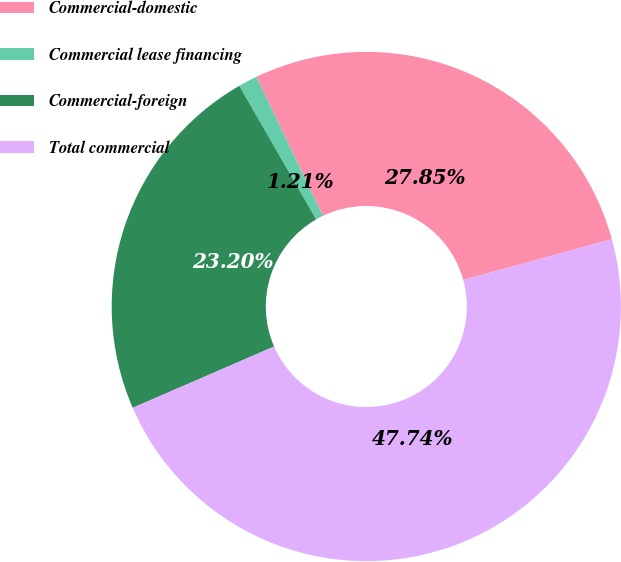Convert chart. <chart><loc_0><loc_0><loc_500><loc_500><pie_chart><fcel>Commercial-domestic<fcel>Commercial lease financing<fcel>Commercial-foreign<fcel>Total commercial<nl><fcel>27.85%<fcel>1.21%<fcel>23.2%<fcel>47.74%<nl></chart> 